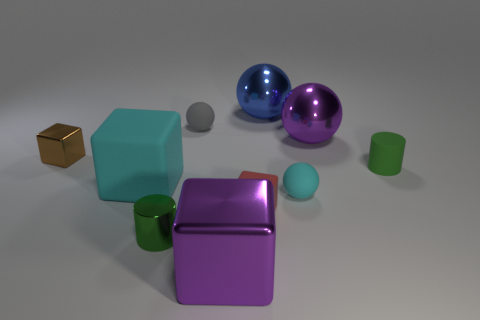There is another large thing that is the same shape as the large cyan object; what is its color?
Provide a succinct answer. Purple. How many objects are both behind the small gray rubber thing and in front of the blue object?
Ensure brevity in your answer.  0. Are there more tiny gray rubber things to the left of the green shiny thing than big purple metal blocks right of the red block?
Your answer should be very brief. No. The brown shiny object is what size?
Ensure brevity in your answer.  Small. Are there any tiny brown metal objects of the same shape as the tiny gray rubber thing?
Your answer should be very brief. No. Does the big cyan rubber thing have the same shape as the small matte thing that is behind the tiny matte cylinder?
Offer a terse response. No. There is a metal object that is in front of the large cyan block and on the right side of the green metal thing; how big is it?
Keep it short and to the point. Large. What number of cyan rubber objects are there?
Keep it short and to the point. 2. There is a brown object that is the same size as the cyan rubber ball; what is it made of?
Ensure brevity in your answer.  Metal. Are there any gray metallic cubes of the same size as the brown object?
Give a very brief answer. No. 